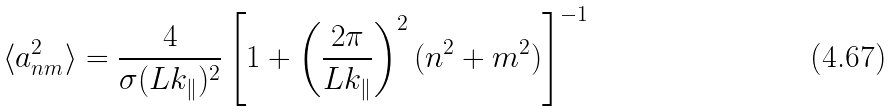<formula> <loc_0><loc_0><loc_500><loc_500>\langle a ^ { 2 } _ { n m } \rangle = \frac { 4 } { \sigma ( L k _ { \| } ) ^ { 2 } } \left [ 1 + \left ( \frac { 2 \pi } { L k _ { \| } } \right ) ^ { 2 } ( n ^ { 2 } + m ^ { 2 } ) \right ] ^ { - 1 }</formula> 